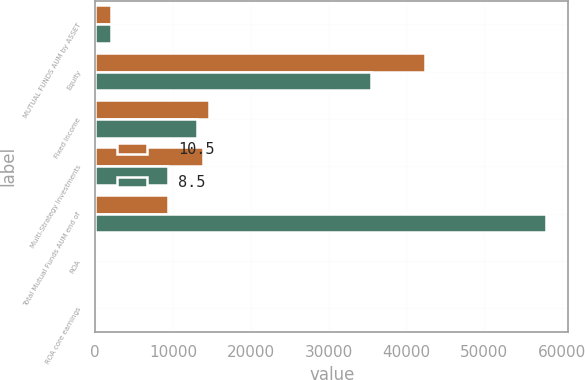<chart> <loc_0><loc_0><loc_500><loc_500><stacked_bar_chart><ecel><fcel>MUTUAL FUNDS AUM by ASSET<fcel>Equity<fcel>Fixed Income<fcel>Multi-Strategy Investments<fcel>Total Mutual Funds AUM end of<fcel>ROA<fcel>ROA core earnings<nl><fcel>10.5<fcel>2013<fcel>42426<fcel>14632<fcel>13860<fcel>9372<fcel>8.2<fcel>8.5<nl><fcel>8.5<fcel>2011<fcel>35489<fcel>13064<fcel>9372<fcel>57925<fcel>10.5<fcel>10.5<nl></chart> 